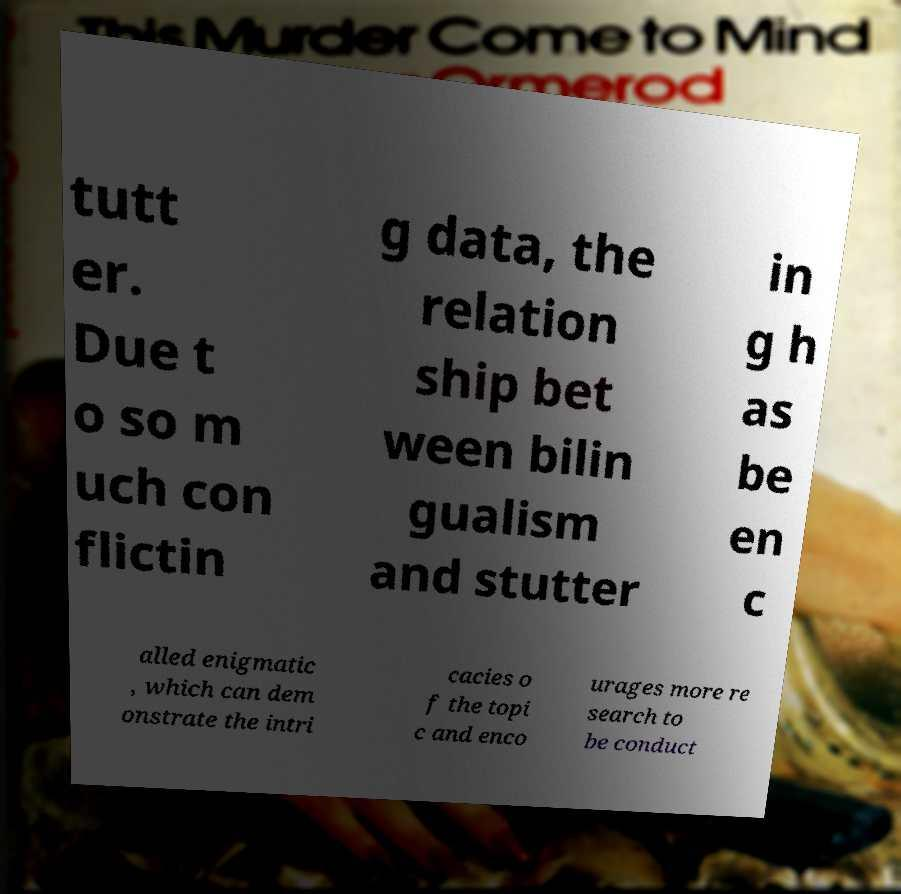Could you assist in decoding the text presented in this image and type it out clearly? tutt er. Due t o so m uch con flictin g data, the relation ship bet ween bilin gualism and stutter in g h as be en c alled enigmatic , which can dem onstrate the intri cacies o f the topi c and enco urages more re search to be conduct 